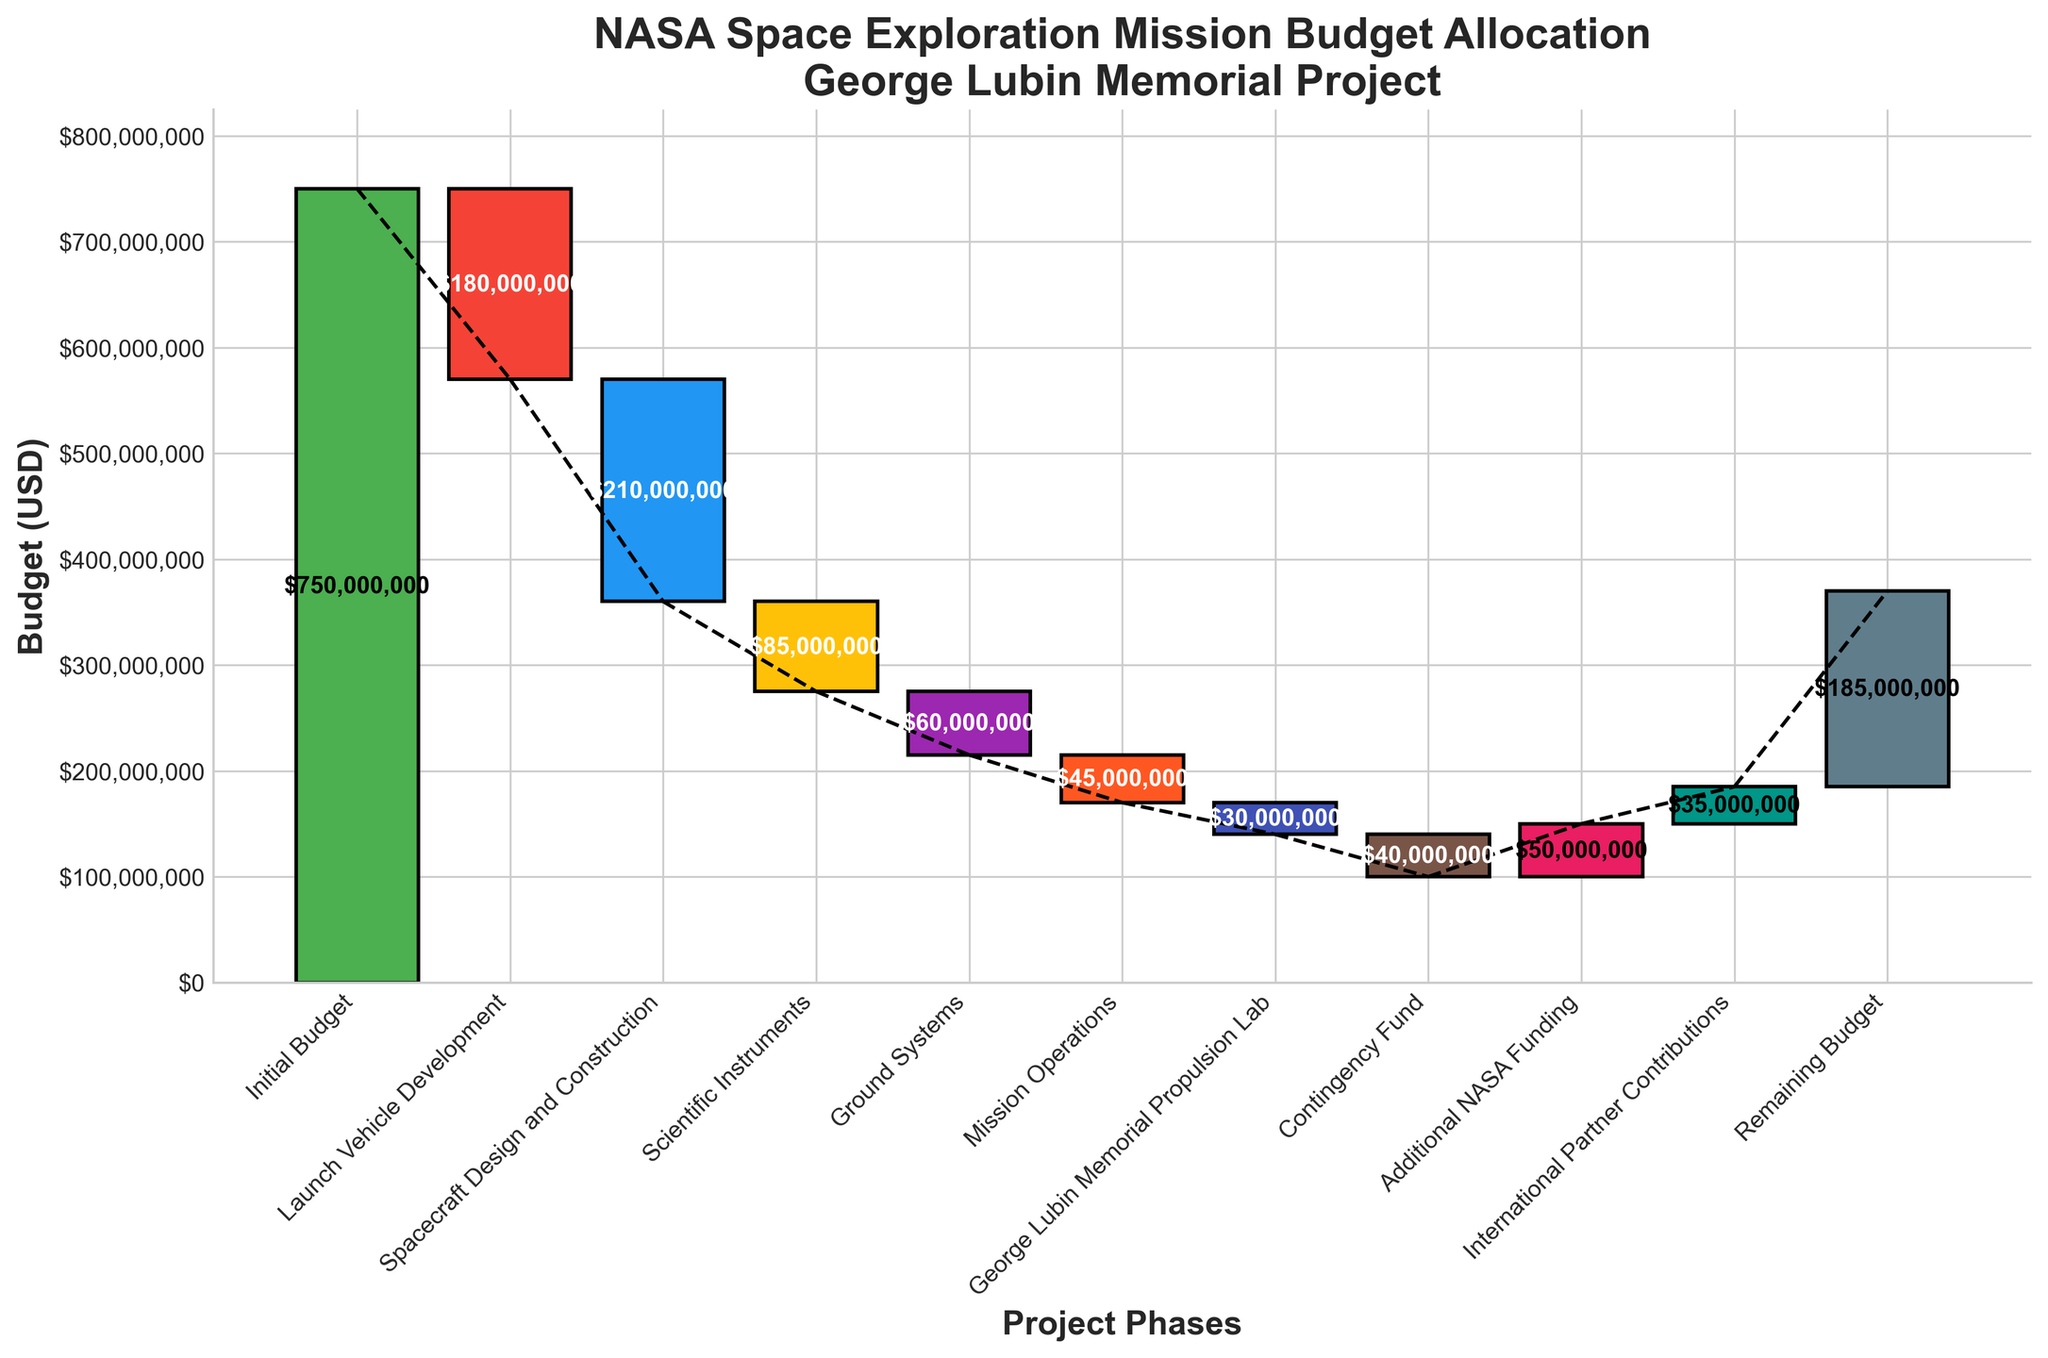What is the title of the chart? The title of the chart is displayed at the top, summarizing the overall content. In this case, the title is specifically about the allocation of budget for NASA's space exploration mission.
Answer: NASA Space Exploration Mission Budget Allocation\nGeorge Lubin Memorial Project How much money was allocated for the Scientific Instruments phase? Each phase's budget allocation is represented by a bar in the waterfall chart. The Scientific Instruments phase has a label of -$85,000,000 above or within its bar.
Answer: $85,000,000 What is the final remaining budget after accounting for all expenses and additional funding sources? The final remaining budget can be found at the end of the waterfall chart, indicated by the last bar with a label of $185,000,000.
Answer: $185,000,000 Which phase had the highest expenditure? To find the phase with the highest expenditure, look for the bar representing the largest negative value. Spacecraft Design and Construction has the largest negative bar with -$210,000,000.
Answer: Spacecraft Design and Construction What is the cumulative budget impact of the launch vehicle development and spacecraft design and construction phases combined? Sum the values of the Launch Vehicle Development (-$180,000,000) and Spacecraft Design and Construction (-$210,000,000). -$180,000,000 + -$210,000,000 = -$390,000,000.
Answer: -$390,000,000 How does the budget for the George Lubin Memorial Propulsion Lab compare to the contingency fund? Compare the value of the George Lubin Memorial Propulsion Lab (-$30,000,000) and the Contingency Fund (-$40,000,000). -$40,000,000 is less than -$30,000,000, so the Contingency Fund is larger.
Answer: The Contingency Fund is larger What is the financial contribution from both International Partner Contributions and Additional NASA Funding combined? Add the values of International Partner Contributions ($35,000,000) and Additional NASA Funding ($50,000,000). $35,000,000 + $50,000,000 = $85,000,000.
Answer: $85,000,000 Did the Ground Systems phase have a higher allocation than the Mission Operations phase? Compare the value of Ground Systems (-$60,000,000) with the Mission Operations (-$45,000,000). -$60,000,000 is less than -$45,000,000, meaning Ground Systems has a higher expenditure.
Answer: Yes Which category follows the scientific instruments in the sequence of budget allocation? Examine the sequence of categories in the waterfall chart. The bar following Scientific Instruments is Ground Systems.
Answer: Ground Systems 